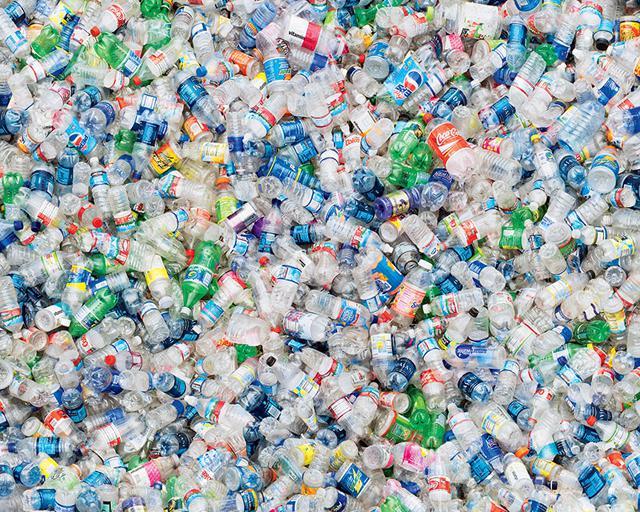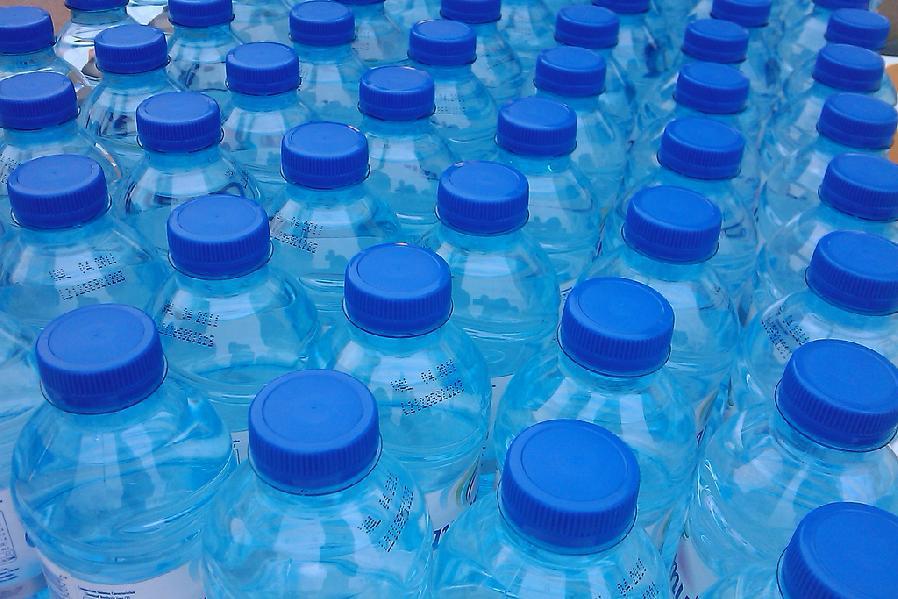The first image is the image on the left, the second image is the image on the right. For the images shown, is this caption "At least one image shows all bottles with white caps." true? Answer yes or no. No. The first image is the image on the left, the second image is the image on the right. For the images shown, is this caption "In at least one image, bottles are capped with only white lids." true? Answer yes or no. No. 